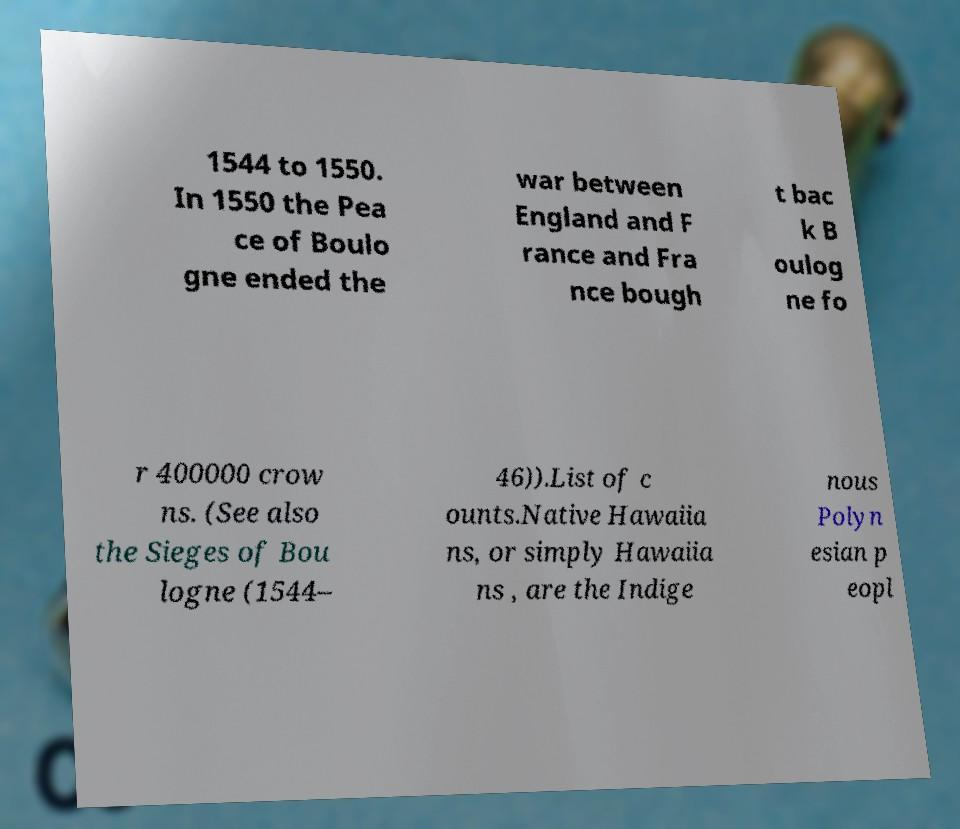Please identify and transcribe the text found in this image. 1544 to 1550. In 1550 the Pea ce of Boulo gne ended the war between England and F rance and Fra nce bough t bac k B oulog ne fo r 400000 crow ns. (See also the Sieges of Bou logne (1544– 46)).List of c ounts.Native Hawaiia ns, or simply Hawaiia ns , are the Indige nous Polyn esian p eopl 